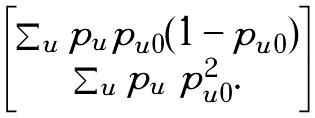Convert formula to latex. <formula><loc_0><loc_0><loc_500><loc_500>\begin{bmatrix} \sum _ { u } p _ { u } p _ { u 0 } ( 1 - p _ { u 0 } ) \\ \sum _ { u } p _ { u } \ p _ { u 0 } ^ { 2 } . \end{bmatrix}</formula> 